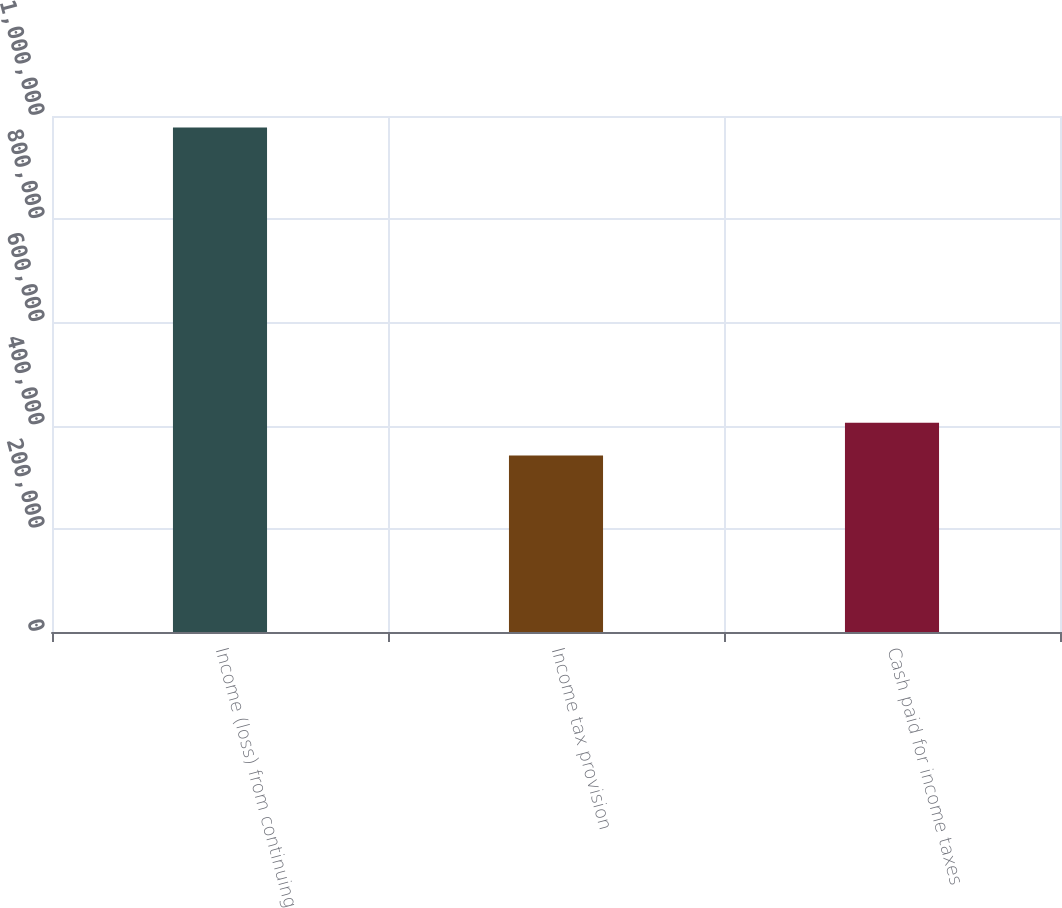Convert chart. <chart><loc_0><loc_0><loc_500><loc_500><bar_chart><fcel>Income (loss) from continuing<fcel>Income tax provision<fcel>Cash paid for income taxes<nl><fcel>977926<fcel>341930<fcel>405530<nl></chart> 